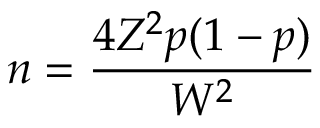Convert formula to latex. <formula><loc_0><loc_0><loc_500><loc_500>n = { \frac { 4 Z ^ { 2 } p ( 1 - p ) } { W ^ { 2 } } }</formula> 